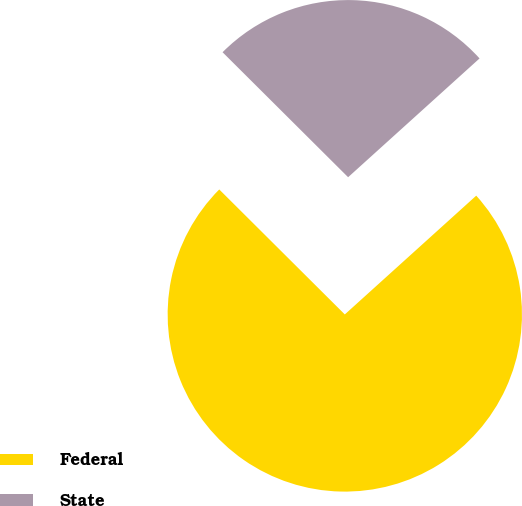Convert chart. <chart><loc_0><loc_0><loc_500><loc_500><pie_chart><fcel>Federal<fcel>State<nl><fcel>74.16%<fcel>25.84%<nl></chart> 